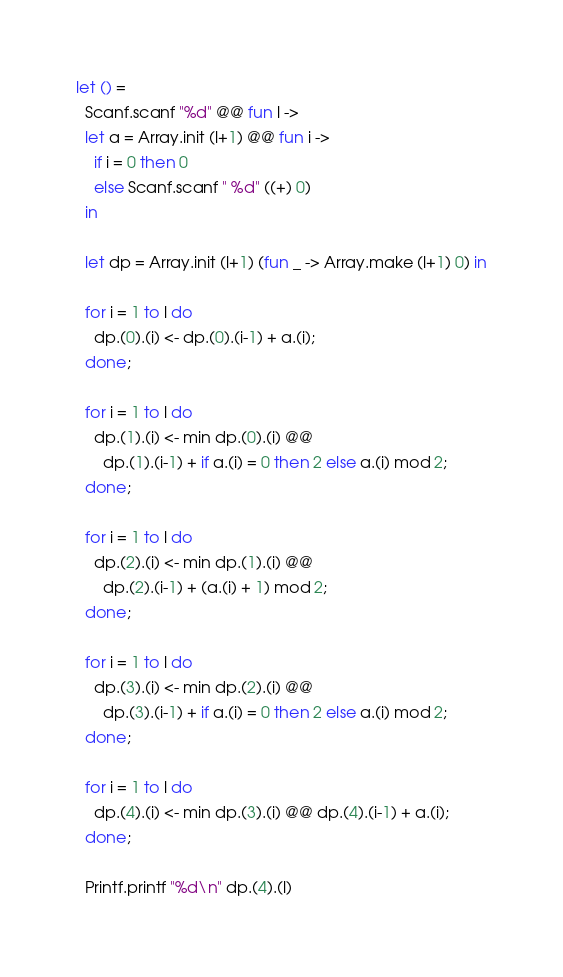<code> <loc_0><loc_0><loc_500><loc_500><_OCaml_>let () =
  Scanf.scanf "%d" @@ fun l ->
  let a = Array.init (l+1) @@ fun i ->
    if i = 0 then 0
    else Scanf.scanf " %d" ((+) 0)
  in

  let dp = Array.init (l+1) (fun _ -> Array.make (l+1) 0) in

  for i = 1 to l do
    dp.(0).(i) <- dp.(0).(i-1) + a.(i);
  done;

  for i = 1 to l do
    dp.(1).(i) <- min dp.(0).(i) @@
      dp.(1).(i-1) + if a.(i) = 0 then 2 else a.(i) mod 2;
  done;

  for i = 1 to l do
    dp.(2).(i) <- min dp.(1).(i) @@
      dp.(2).(i-1) + (a.(i) + 1) mod 2;
  done;

  for i = 1 to l do
    dp.(3).(i) <- min dp.(2).(i) @@
      dp.(3).(i-1) + if a.(i) = 0 then 2 else a.(i) mod 2;
  done;

  for i = 1 to l do
    dp.(4).(i) <- min dp.(3).(i) @@ dp.(4).(i-1) + a.(i);
  done;

  Printf.printf "%d\n" dp.(4).(l)</code> 